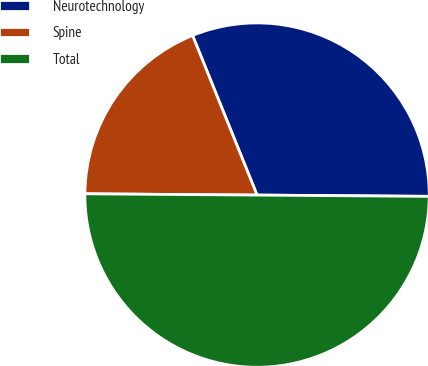Convert chart. <chart><loc_0><loc_0><loc_500><loc_500><pie_chart><fcel>Neurotechnology<fcel>Spine<fcel>Total<nl><fcel>31.23%<fcel>18.77%<fcel>50.0%<nl></chart> 